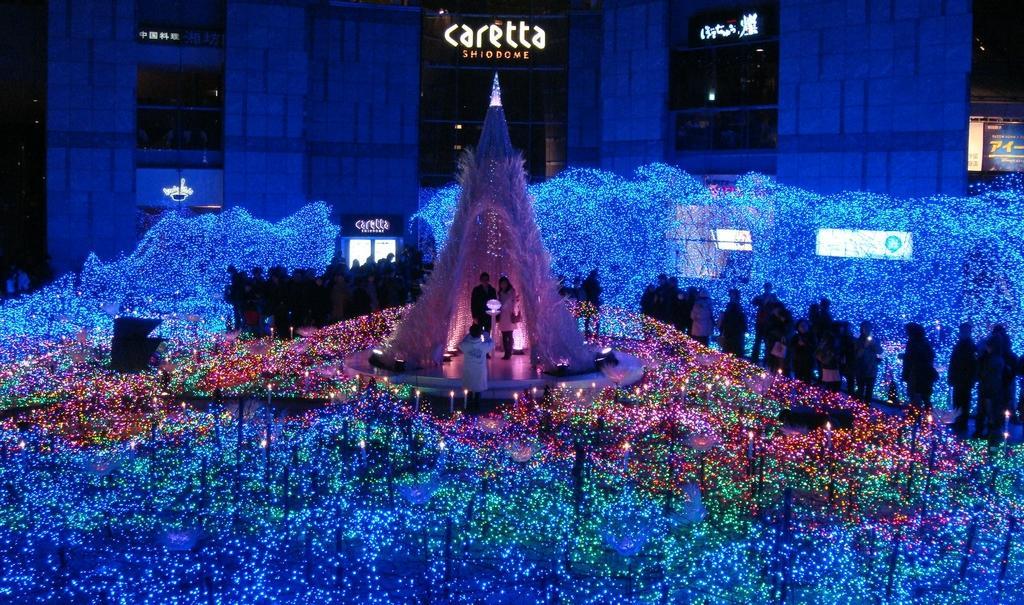How would you summarize this image in a sentence or two? In this image, I can see groups of people standing and two persons standing under a decorative shelter. There are candles, lights, boards and focus lights. In the background, I can see a building with name boards. 